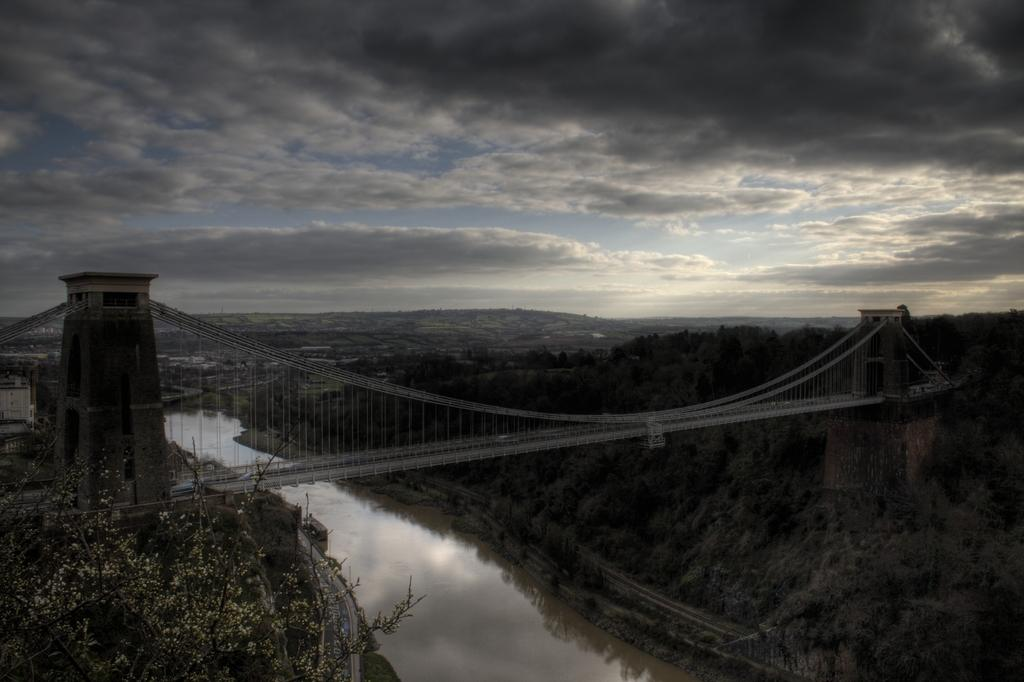What structure can be seen in the image? There is a bridge in the image. What is visible in the background of the image? There is water visible in the background of the image. What type of vegetation is present in the image? There are trees with green color in the image. What type of man-made structures can be seen in the image? There are buildings in the image. What is the color of the sky in the image? The sky is blue, white, and gray in color. What is the value of the record being played in the image? There is no record or music player present in the image, so it is not possible to determine the value of a record. 